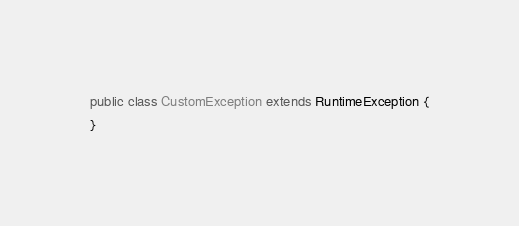<code> <loc_0><loc_0><loc_500><loc_500><_Java_>
public class CustomException extends RuntimeException {
}
</code> 